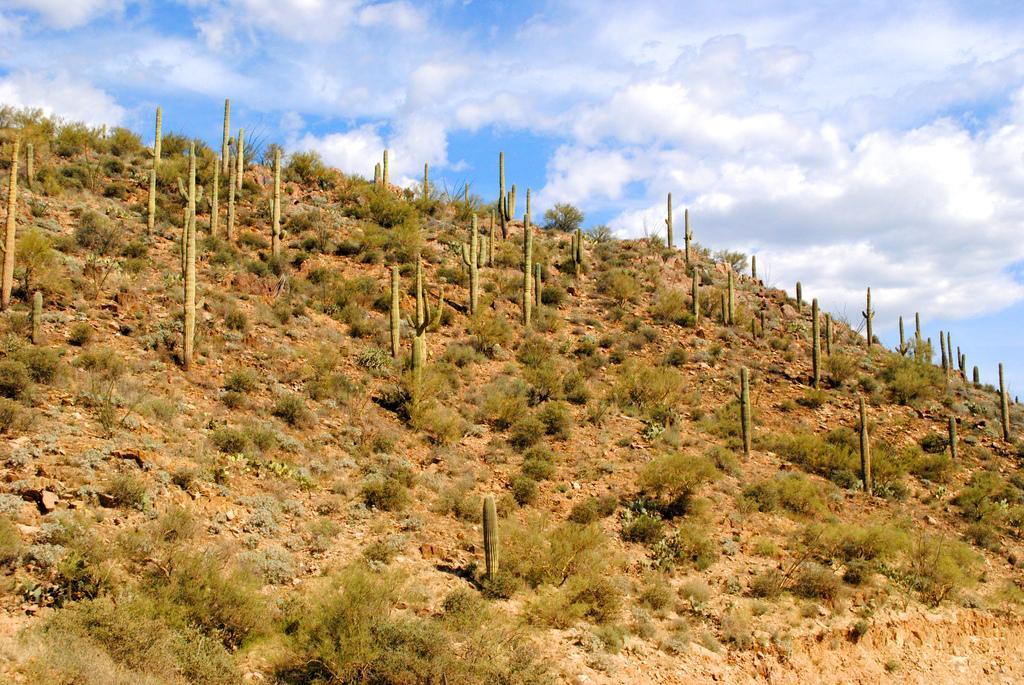In one or two sentences, can you explain what this image depicts? In the picture we can see the part of the hill surface with plants and behind it, we can see the sky with clouds. 